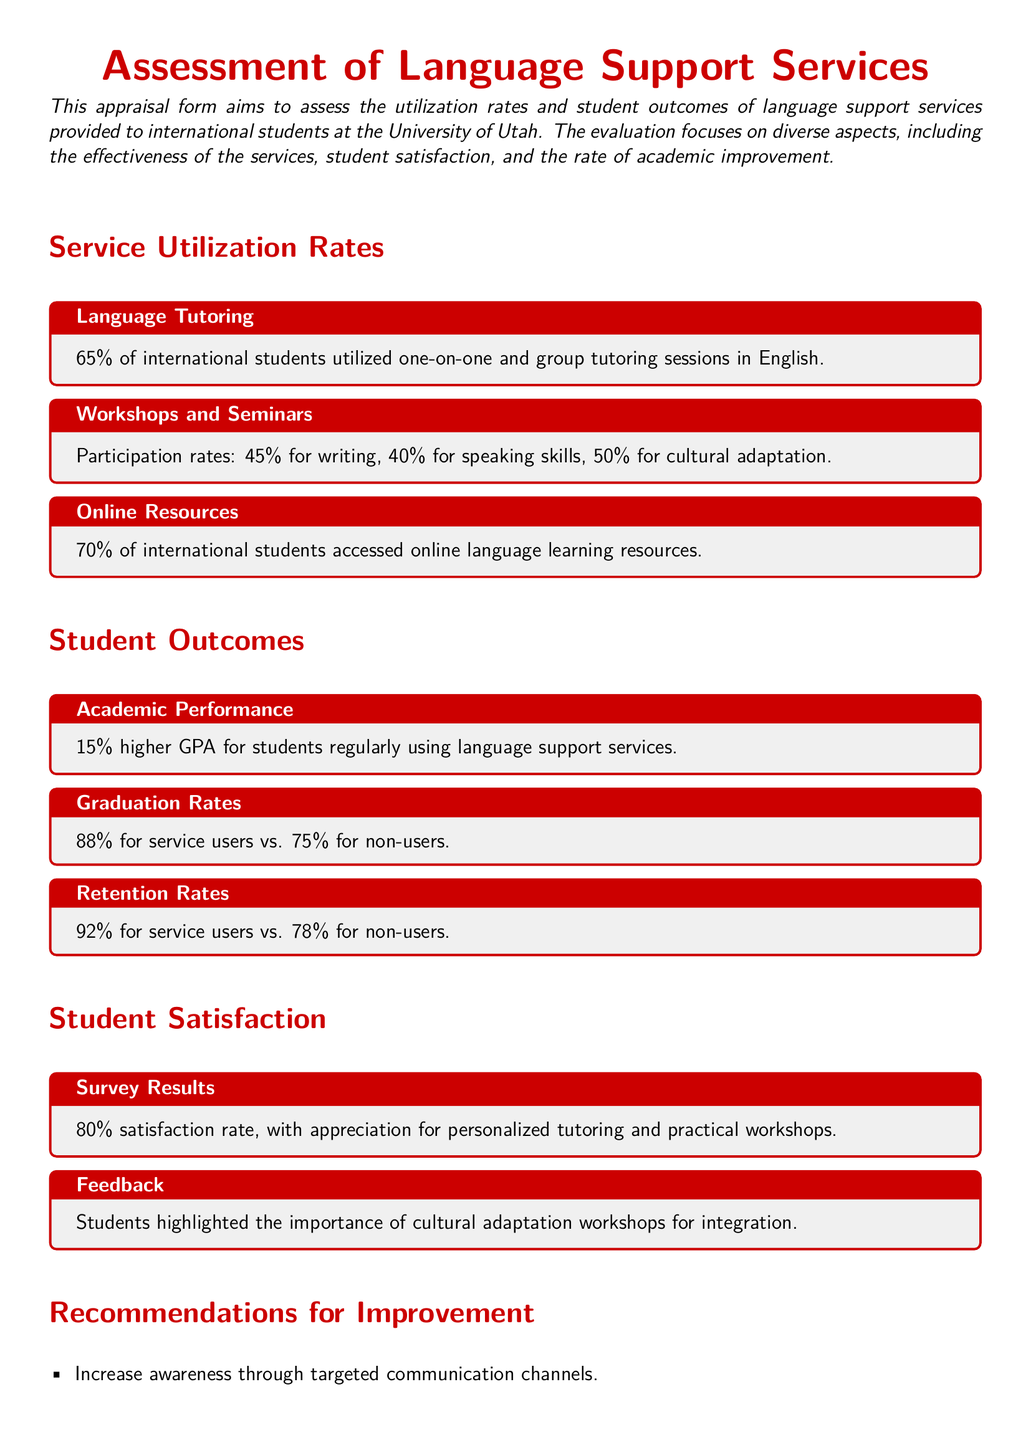What is the utilization rate for online resources? The document states that 70% of international students accessed online language learning resources.
Answer: 70% What is the GPA increase for students using language support services? Students regularly using language support services have a 15% higher GPA compared to their peers.
Answer: 15% What percentage of international students utilized language tutoring services? According to the document, 65% of international students utilized one-on-one and group tutoring sessions in English.
Answer: 65% What is the graduation rate for service users? The appraisal form indicates that the graduation rate for service users is 88%.
Answer: 88% Which service had the lowest participation rate among workshops? The participation rates indicate that speaking skills workshops had a participation rate of 40%, which is the lowest.
Answer: Speaking skills What recommendation is given for improving awareness of language services? The plan suggests increasing awareness through targeted communication channels.
Answer: Increase awareness What percentage of users reported satisfaction with the services? The document presents an 80% satisfaction rate among users of language support services.
Answer: 80% What is the retention rate for non-users of language support services? Non-users have a retention rate of 78%, as stated in the document.
Answer: 78% 